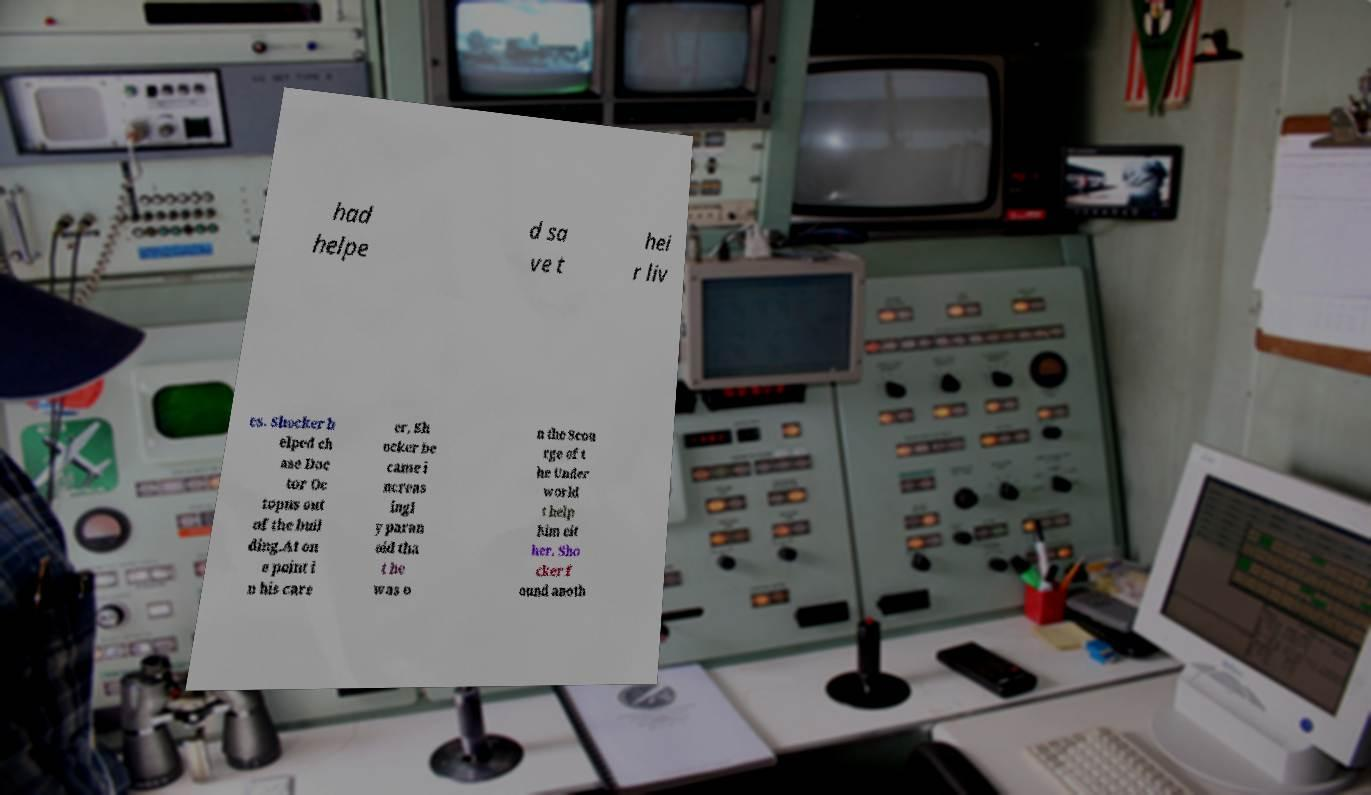Please read and relay the text visible in this image. What does it say? had helpe d sa ve t hei r liv es. Shocker h elped ch ase Doc tor Oc topus out of the buil ding.At on e point i n his care er, Sh ocker be came i ncreas ingl y paran oid tha t he was o n the Scou rge of t he Under world t help him eit her. Sho cker f ound anoth 